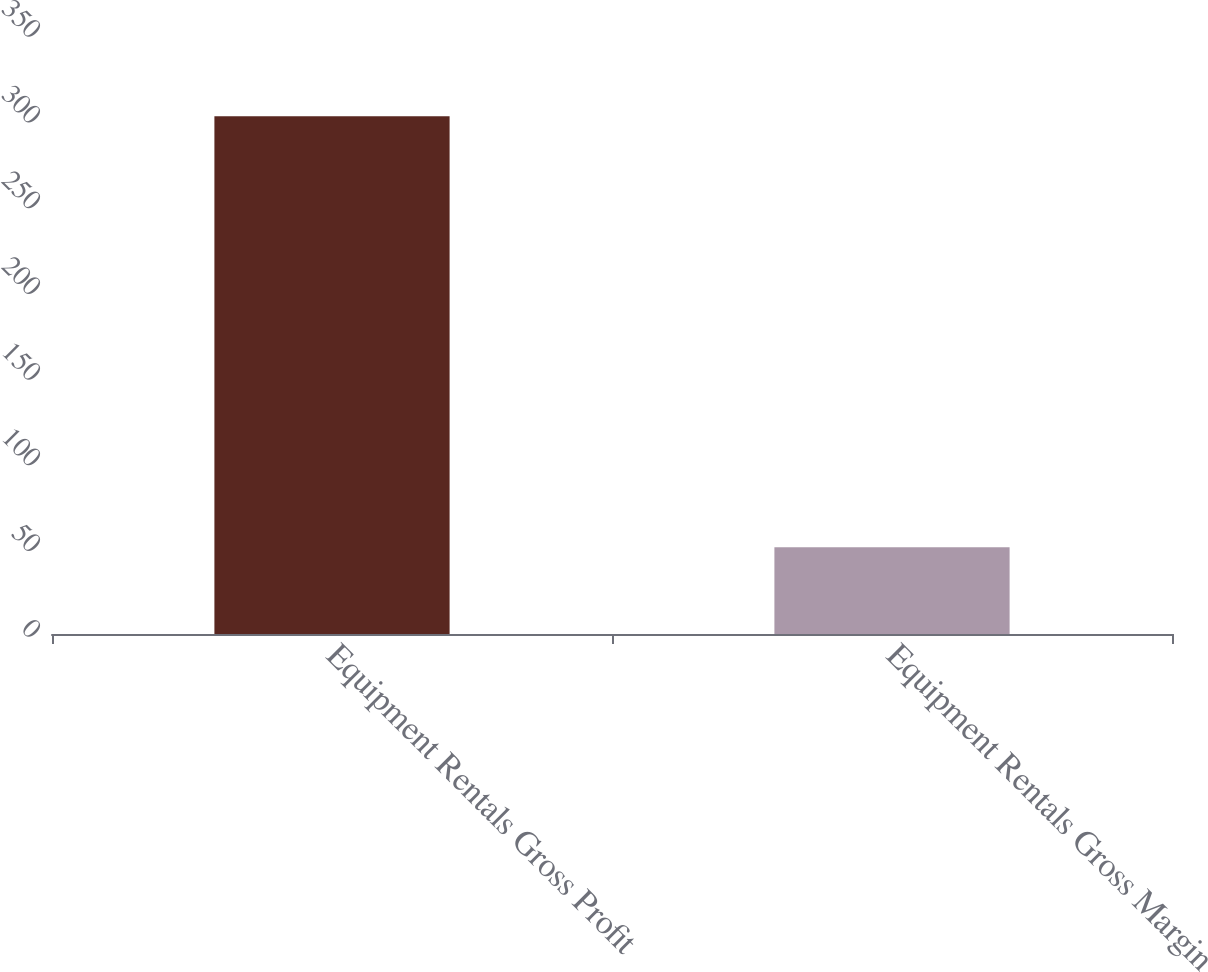<chart> <loc_0><loc_0><loc_500><loc_500><bar_chart><fcel>Equipment Rentals Gross Profit<fcel>Equipment Rentals Gross Margin<nl><fcel>302<fcel>50.6<nl></chart> 